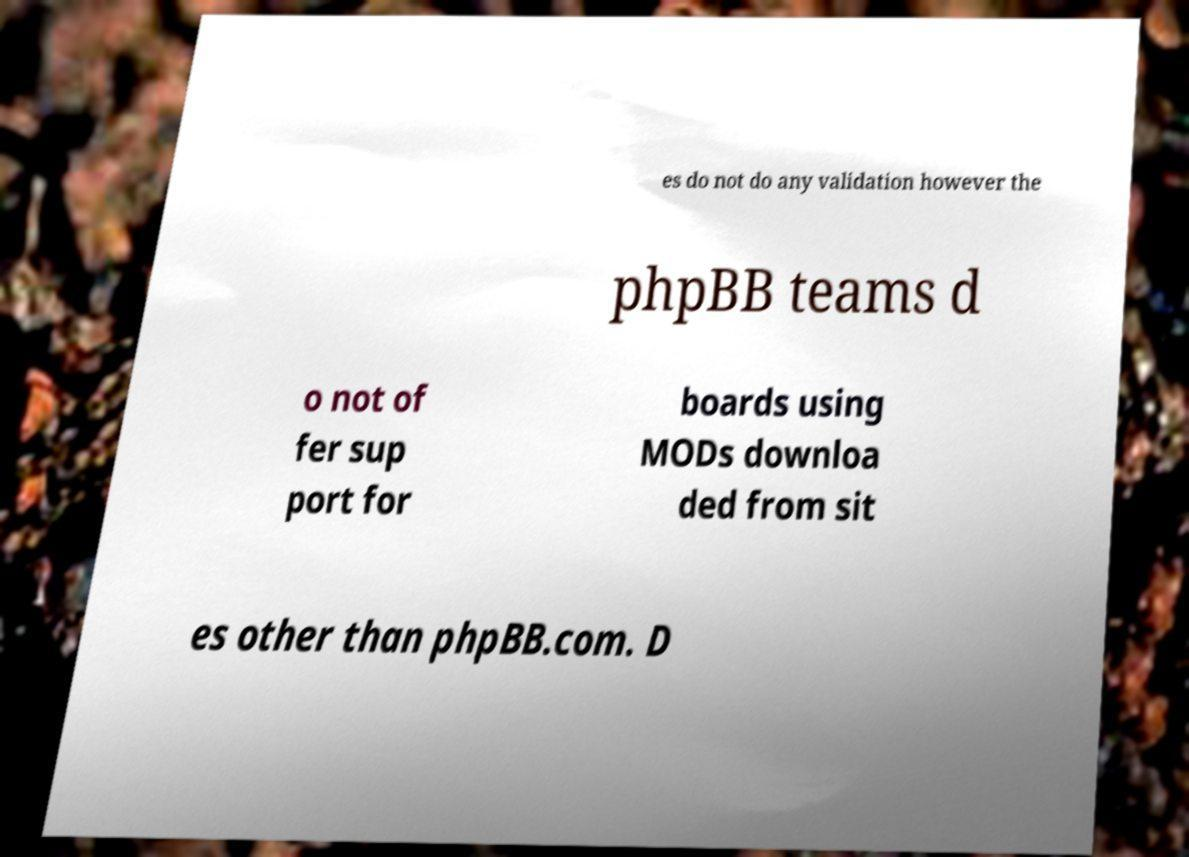Could you assist in decoding the text presented in this image and type it out clearly? es do not do any validation however the phpBB teams d o not of fer sup port for boards using MODs downloa ded from sit es other than phpBB.com. D 